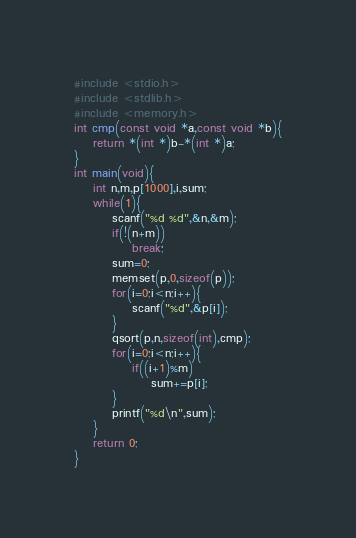<code> <loc_0><loc_0><loc_500><loc_500><_C_>#include <stdio.h>
#include <stdlib.h>
#include <memory.h>
int cmp(const void *a,const void *b){
	return *(int *)b-*(int *)a;
}
int main(void){
	int n,m,p[1000],i,sum;
	while(1){
		scanf("%d %d",&n,&m);
		if(!(n+m))
			break;
		sum=0;
		memset(p,0,sizeof(p));
		for(i=0;i<n;i++){
			scanf("%d",&p[i]);
		}
		qsort(p,n,sizeof(int),cmp);
		for(i=0;i<n;i++){
			if((i+1)%m)
				sum+=p[i];
		}
		printf("%d\n",sum);
	}
	return 0;
}</code> 